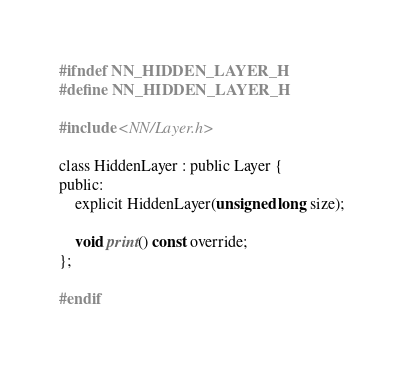Convert code to text. <code><loc_0><loc_0><loc_500><loc_500><_C_>#ifndef NN_HIDDEN_LAYER_H
#define NN_HIDDEN_LAYER_H

#include <NN/Layer.h>

class HiddenLayer : public Layer {
public:
    explicit HiddenLayer(unsigned long size);

    void print() const override;
};

#endif

</code> 